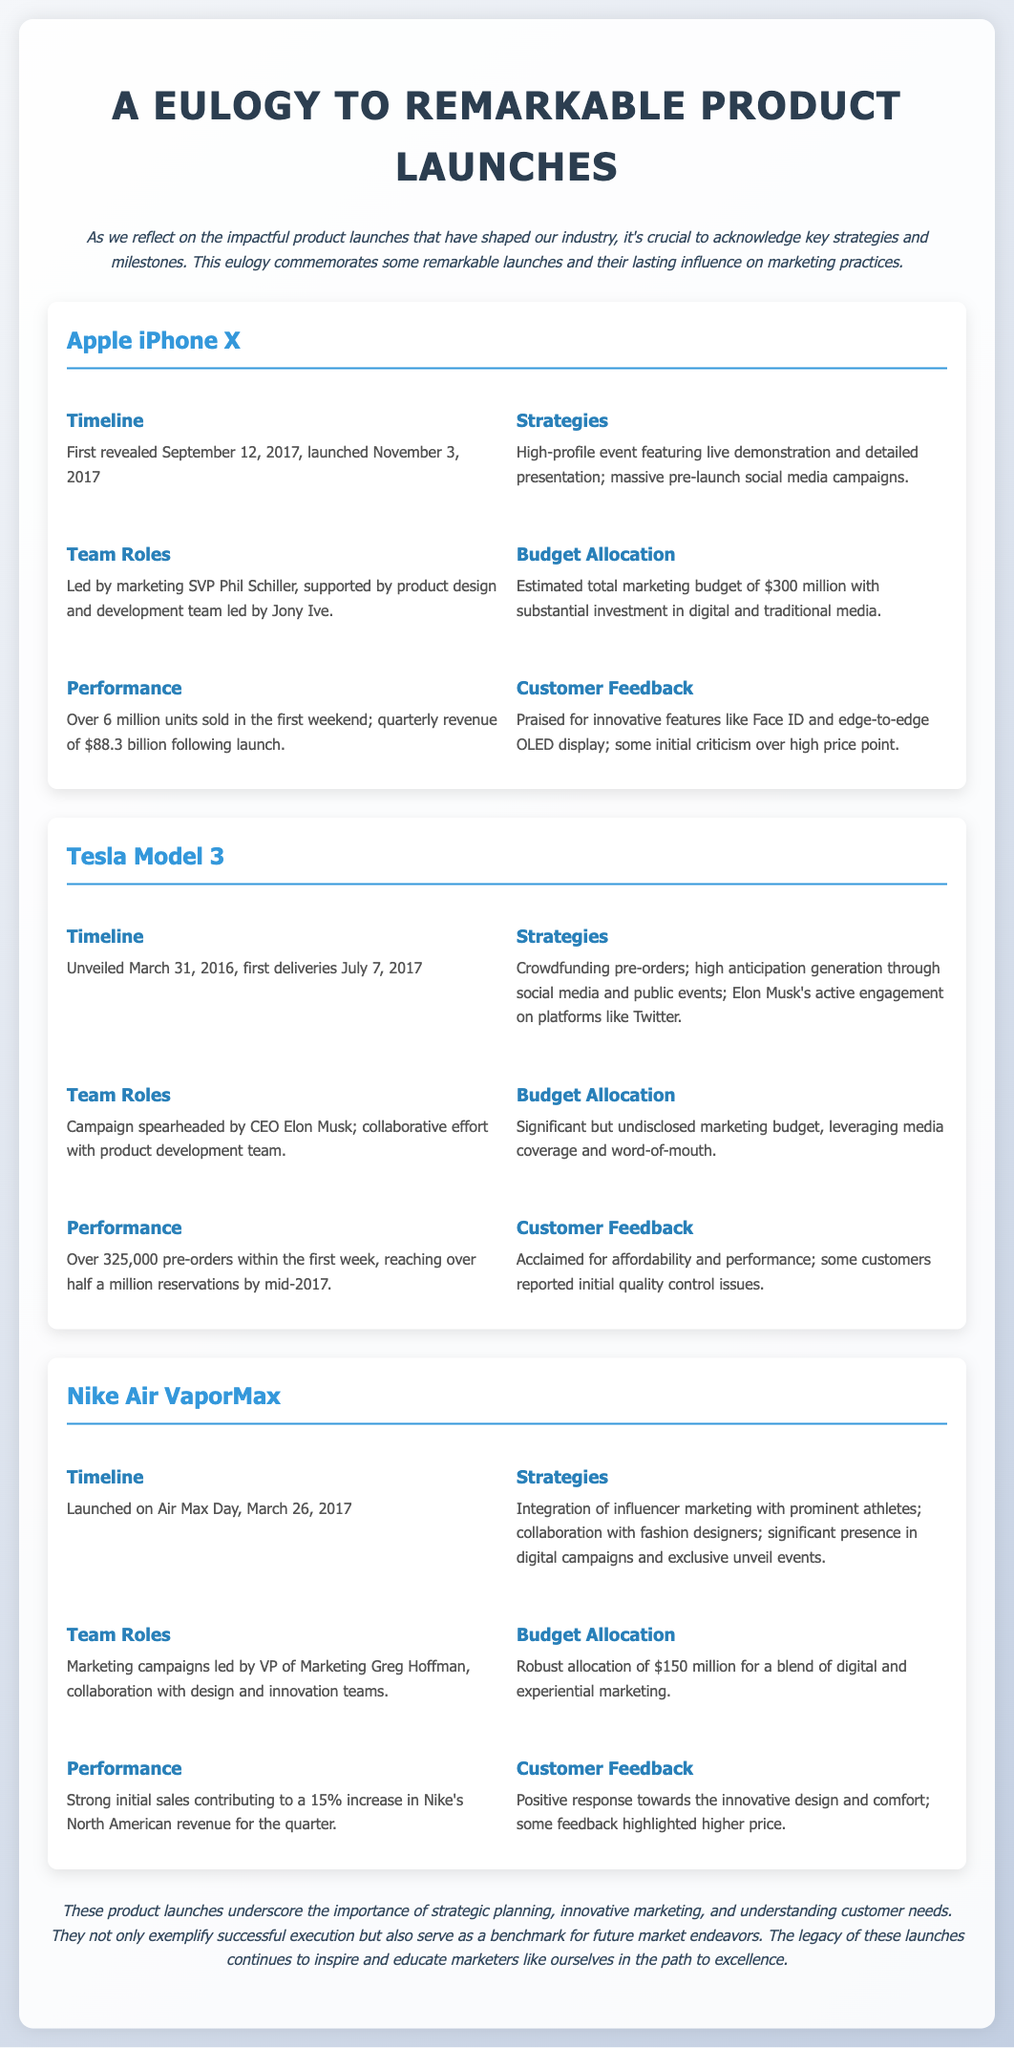what was the launch date of the iPhone X? The iPhone X was launched on November 3, 2017.
Answer: November 3, 2017 who led the marketing for Tesla Model 3? The campaign was spearheaded by CEO Elon Musk.
Answer: Elon Musk how much was the marketing budget for the Nike Air VaporMax? The budget allocation for Nike Air VaporMax was $150 million.
Answer: $150 million what key feature was praised in customer feedback for the iPhone X? The iPhone X was praised for its innovative features like Face ID.
Answer: Face ID what was the sales performance of the Tesla Model 3 in the first week? Over 325,000 pre-orders were made within the first week.
Answer: 325,000 pre-orders what marketing strategy did Nike Air VaporMax primarily utilize? Nike Air VaporMax integrated influencer marketing with prominent athletes.
Answer: Influencer marketing what was the quarterly revenue following the iPhone X launch? The quarterly revenue following the iPhone X launch was $88.3 billion.
Answer: $88.3 billion when was the Tesla Model 3 unveiled? The Tesla Model 3 was unveiled on March 31, 2016.
Answer: March 31, 2016 how did the sales of Nike Air VaporMax impact Nike's revenue? Sales contributed to a 15% increase in Nike's North American revenue for the quarter.
Answer: 15% increase 